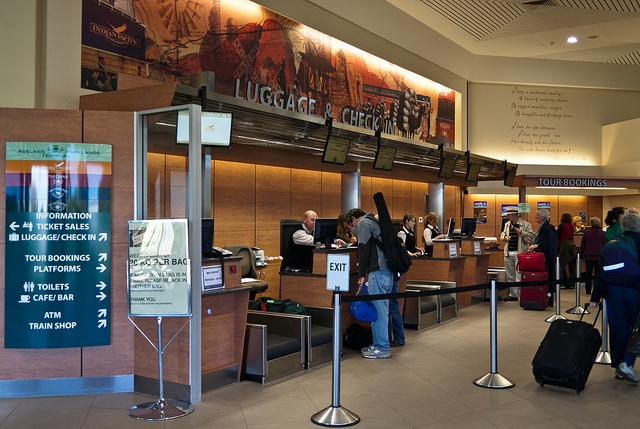Describe the objects in this image and their specific colors. I can see people in gray, black, and navy tones, suitcase in gray, black, and tan tones, people in gray, black, and blue tones, backpack in gray, black, navy, and lightblue tones, and people in gray, black, maroon, and tan tones in this image. 